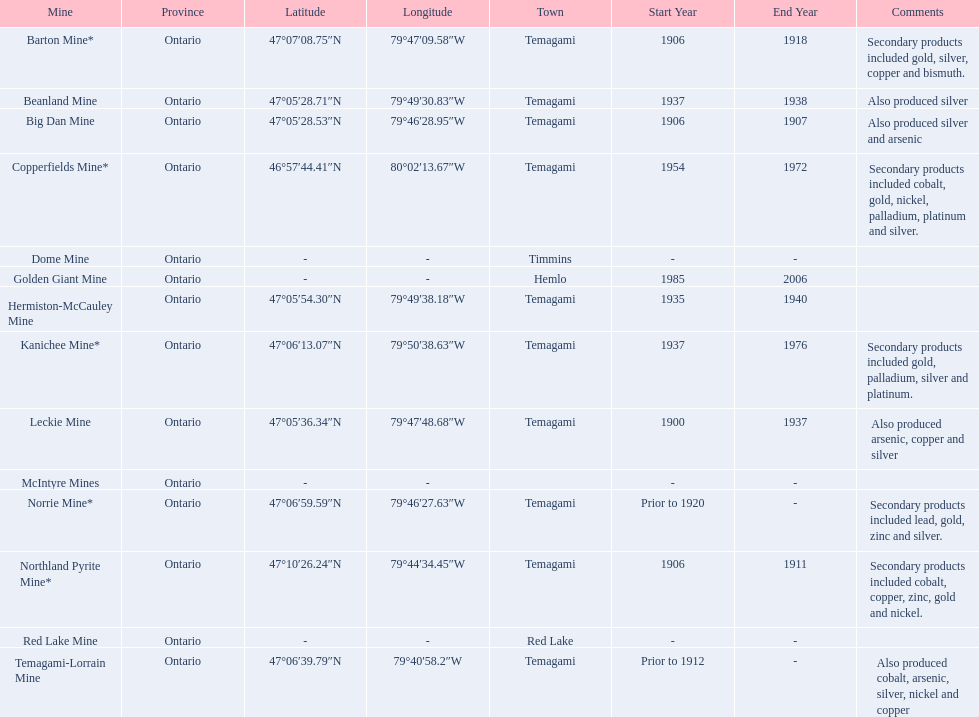How many times is temagami listedon the list? 10. 